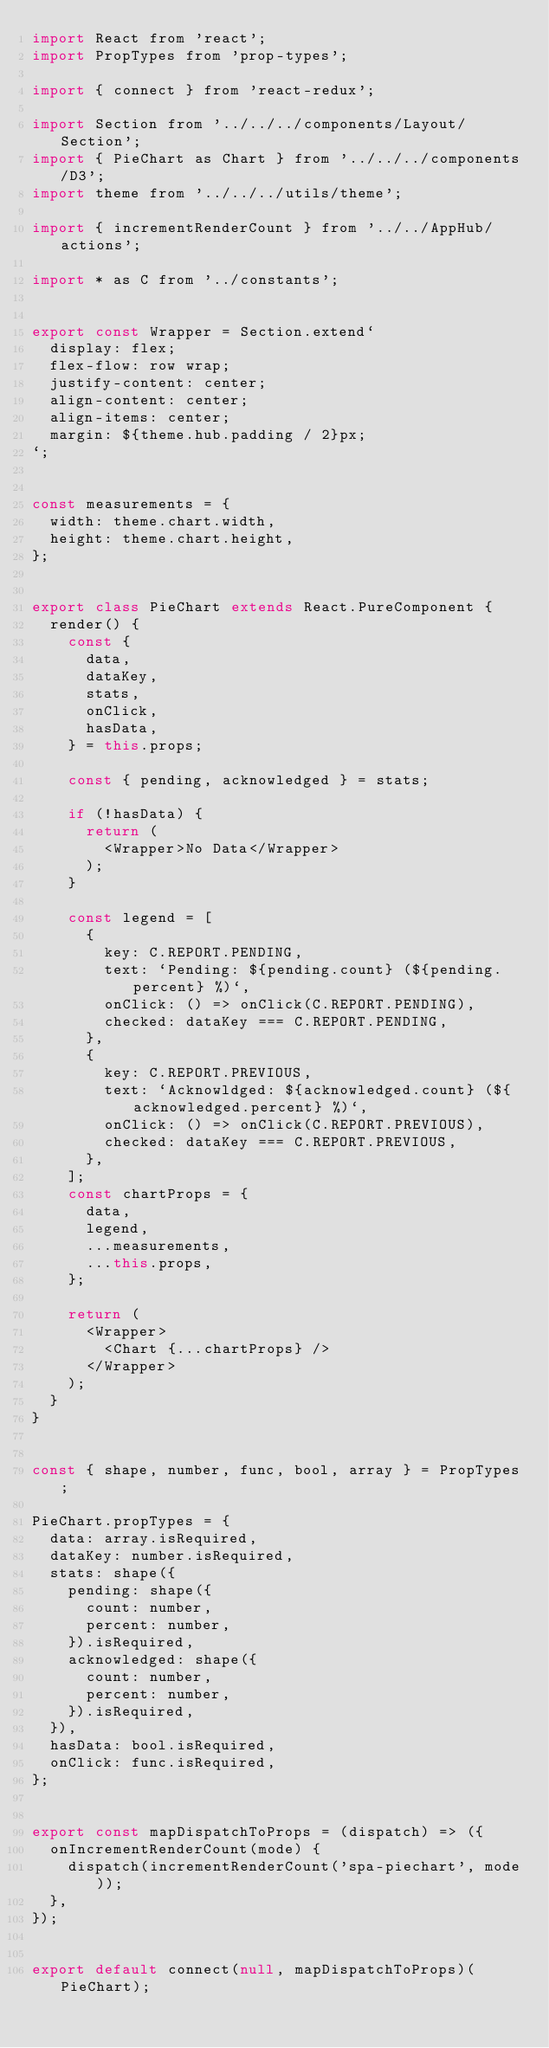<code> <loc_0><loc_0><loc_500><loc_500><_JavaScript_>import React from 'react';
import PropTypes from 'prop-types';

import { connect } from 'react-redux';

import Section from '../../../components/Layout/Section';
import { PieChart as Chart } from '../../../components/D3';
import theme from '../../../utils/theme';

import { incrementRenderCount } from '../../AppHub/actions';

import * as C from '../constants';


export const Wrapper = Section.extend`
  display: flex;
  flex-flow: row wrap;
  justify-content: center;
  align-content: center;
  align-items: center;
  margin: ${theme.hub.padding / 2}px;
`;


const measurements = {
  width: theme.chart.width,
  height: theme.chart.height,
};


export class PieChart extends React.PureComponent {
  render() {
    const {
      data,
      dataKey,
      stats,
      onClick,
      hasData,
    } = this.props;

    const { pending, acknowledged } = stats;

    if (!hasData) {
      return (
        <Wrapper>No Data</Wrapper>
      );
    }

    const legend = [
      {
        key: C.REPORT.PENDING,
        text: `Pending: ${pending.count} (${pending.percent} %)`,
        onClick: () => onClick(C.REPORT.PENDING),
        checked: dataKey === C.REPORT.PENDING,
      },
      {
        key: C.REPORT.PREVIOUS,
        text: `Acknowldged: ${acknowledged.count} (${acknowledged.percent} %)`,
        onClick: () => onClick(C.REPORT.PREVIOUS),
        checked: dataKey === C.REPORT.PREVIOUS,
      },
    ];
    const chartProps = {
      data,
      legend,
      ...measurements,
      ...this.props,
    };

    return (
      <Wrapper>
        <Chart {...chartProps} />
      </Wrapper>
    );
  }
}


const { shape, number, func, bool, array } = PropTypes;

PieChart.propTypes = {
  data: array.isRequired,
  dataKey: number.isRequired,
  stats: shape({
    pending: shape({
      count: number,
      percent: number,
    }).isRequired,
    acknowledged: shape({
      count: number,
      percent: number,
    }).isRequired,
  }),
  hasData: bool.isRequired,
  onClick: func.isRequired,
};


export const mapDispatchToProps = (dispatch) => ({
  onIncrementRenderCount(mode) {
    dispatch(incrementRenderCount('spa-piechart', mode));
  },
});


export default connect(null, mapDispatchToProps)(PieChart);
</code> 